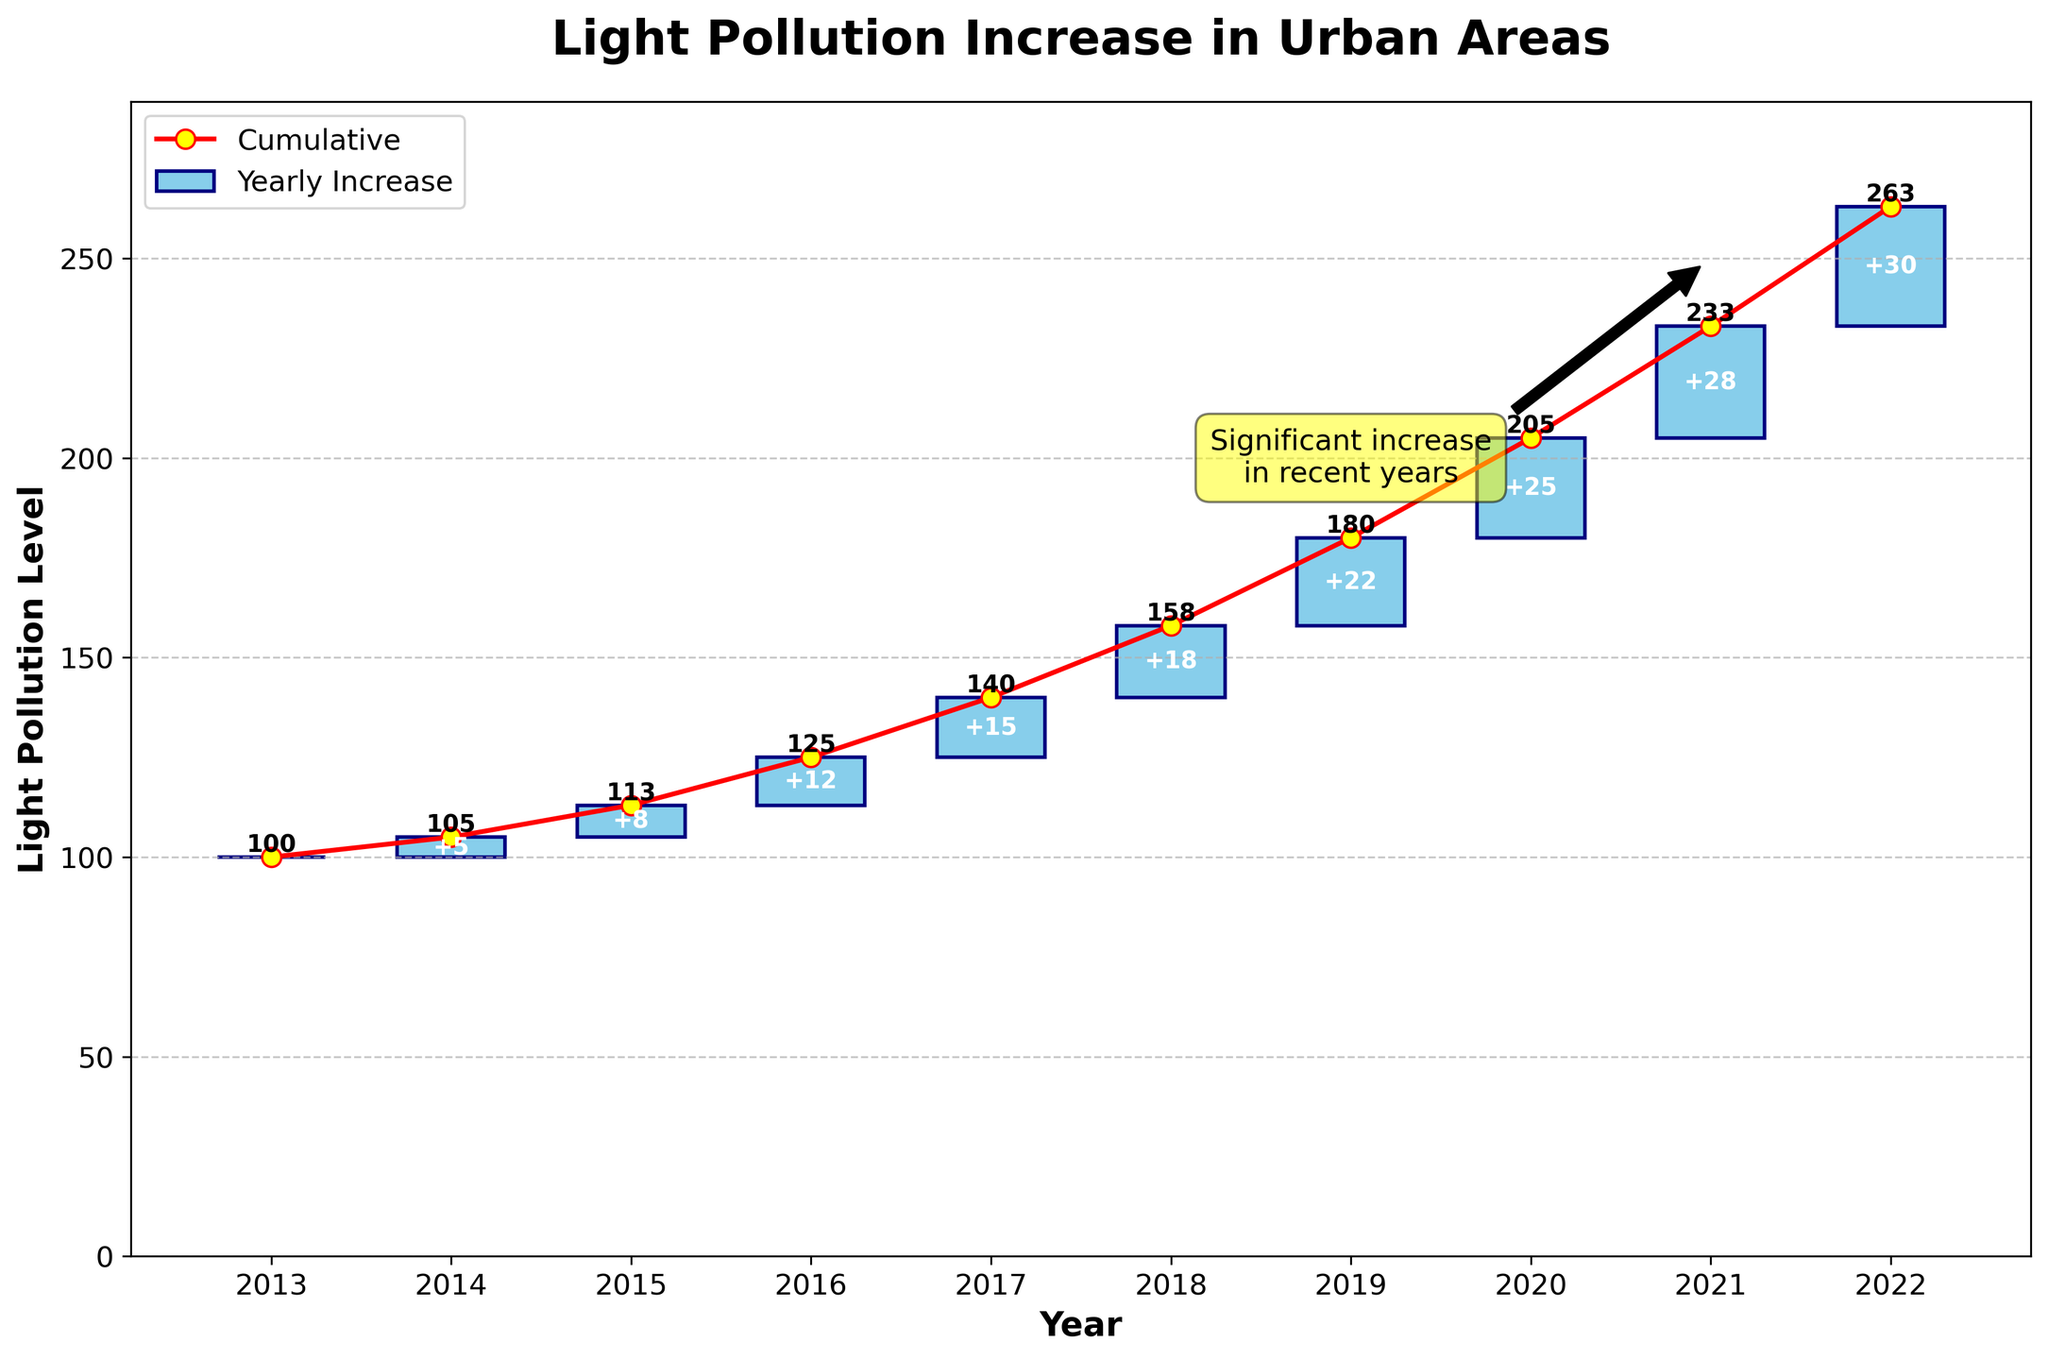what is the title of the chart? The title of the chart is typically written at the top and describes the main subject of the chart. In this case, it's located above the figure and states the topic being addressed, which is light pollution increase.
Answer: Light Pollution Increase in Urban Areas what is the cumulative light pollution level in 2020? To find the cumulative level for 2020, look at the value on the y-axis corresponding to the bar or line point for the year 2020. Refer to the 'Cumulative' data for 2020.
Answer: 205 what is the difference in light pollution increase between 2014 and 2016? Find the yearly increase columns for both 2014 and 2016 and then calculate the difference: 12 (2016) - 5 (2014).
Answer: 7 which year had the highest yearly increase in light pollution? Examine the 'Change' values for all years and identify the year with the highest value.
Answer: 2022 how many years show an increase of more than 20 units? Count the number of years where the yearly increase ('Change') exceeds 20 units by checking the respective bars.
Answer: 3 what is the average annual increase in light pollution from 2013 to 2022? Sum the annual increases and divide by the number of years (10). (5+8+12+15+18+22+25+28+30)/10
Answer: 16.3 how much did the cumulative light pollution level increase from 2013 to 2022? Subtract the cumulative light pollution level in 2013 from the level in 2022. 263 (2022) - 100 (2013)
Answer: 163 is there a significant increase in recent years? The annotation in the figure highlights a significant increase in recent years by pointing to the higher values in the latter part of the decade, indicating more pronounced growth.
Answer: Yes between which consecutive years is the largest increase observed? Compare the yearly increases between pairs of consecutive years and identify the largest: 30 (2022) from 28 (2021) for the largest change.
Answer: 2021 and 2022 